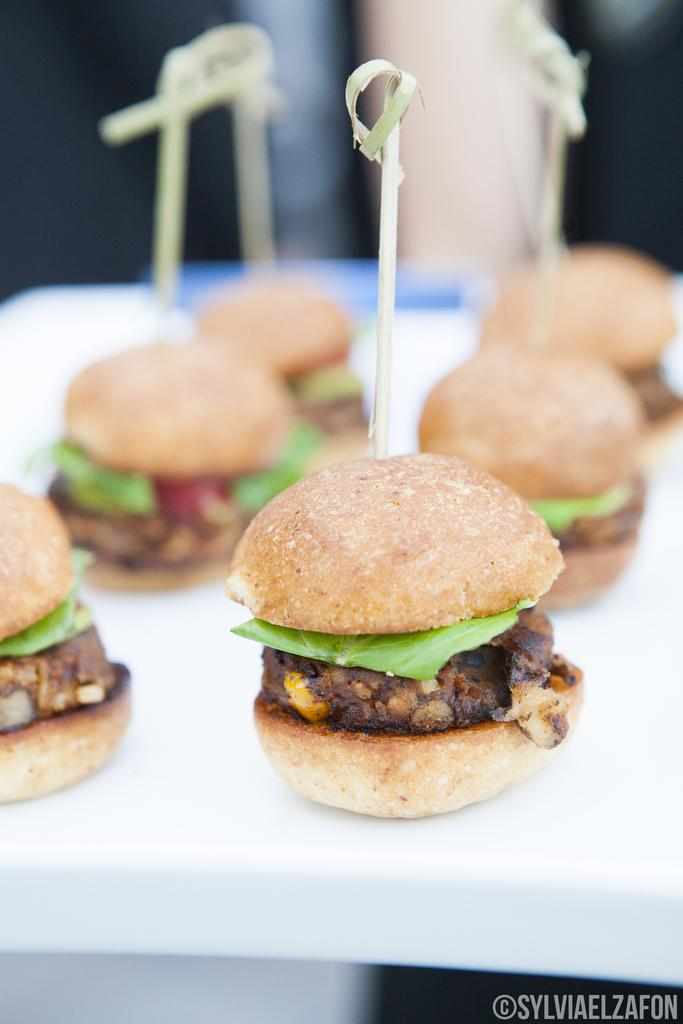What type of food is shown in the image? There are burgers in the image. How big are the burgers? The burgers are small. Is there any specific burger that stands out in the image? One burger is highlighted in the image. What type of musical instrument is being played in the image? There is no musical instrument or any indication of music being played in the image; it features small burgers. 